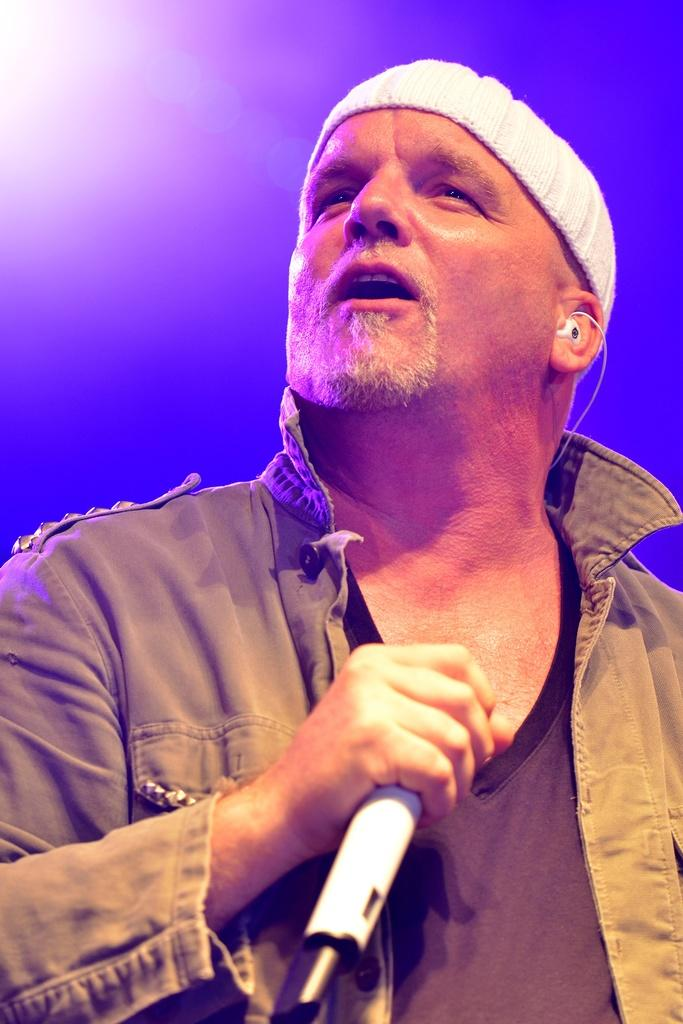Who is the main subject in the image? There is a person in the center of the image. What is the person wearing? The person is wearing a coat. What object is the person holding in his hand? The person is holding a microphone in his hand. What type of wool is used to make the coat in the image? There is no information about the type of wool used to make the coat in the image. 